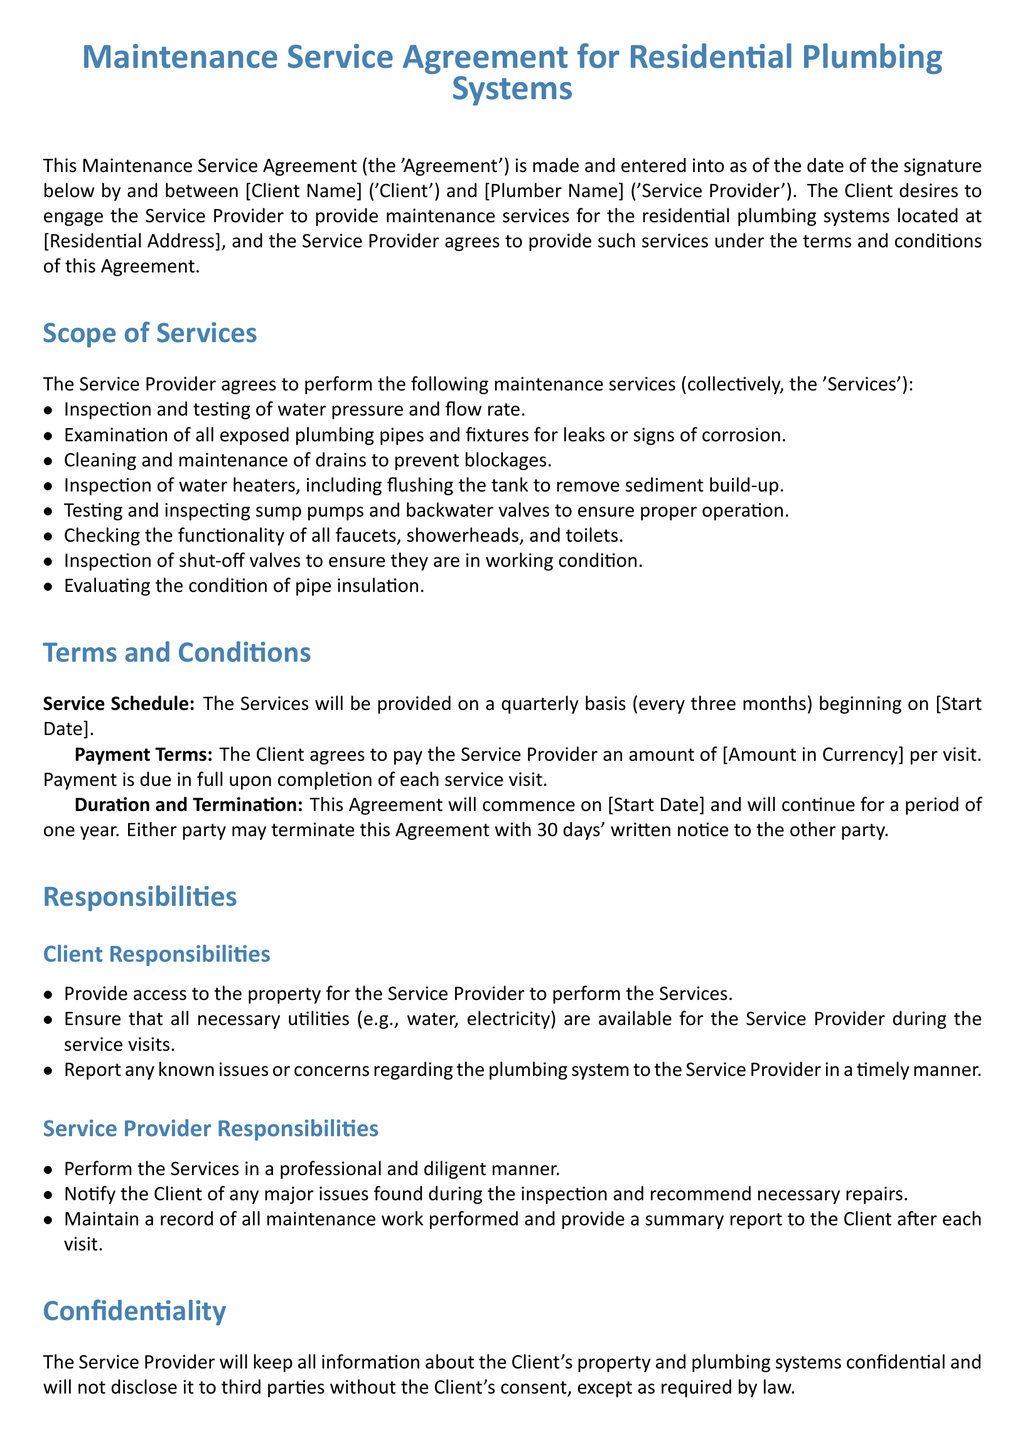What is the date of the Agreement? The Agreement is made and entered as of the date of the signature below.
Answer: [date of signature] What services are performed quarterly? The services provided on a quarterly basis are listed in the Scope of Services section.
Answer: Inspection and testing of water pressure and flow rate What is the payment due upon completion of each service visit? The payment terms specify the amount due for each service visit.
Answer: [Amount in Currency] What is the duration of the Agreement? The duration is mentioned in the Duration and Termination section of the document.
Answer: one year How much notice is required for termination? The termination details specify the required notice period.
Answer: 30 days Who is responsible for providing access to the property? The responsibilities of the Client outline this requirement.
Answer: Client What must the Service Provider do after each service visit? The responsibilities of the Service Provider include maintaining records and providing updates after each visit.
Answer: Provide a summary report What color is used for headings in the document? The document specifies the color used for the headings in the title format settings.
Answer: plumberblue What must the Client report in a timely manner? The Client responsibilities section mentions issues that need to be reported.
Answer: Known issues or concerns regarding the plumbing system 